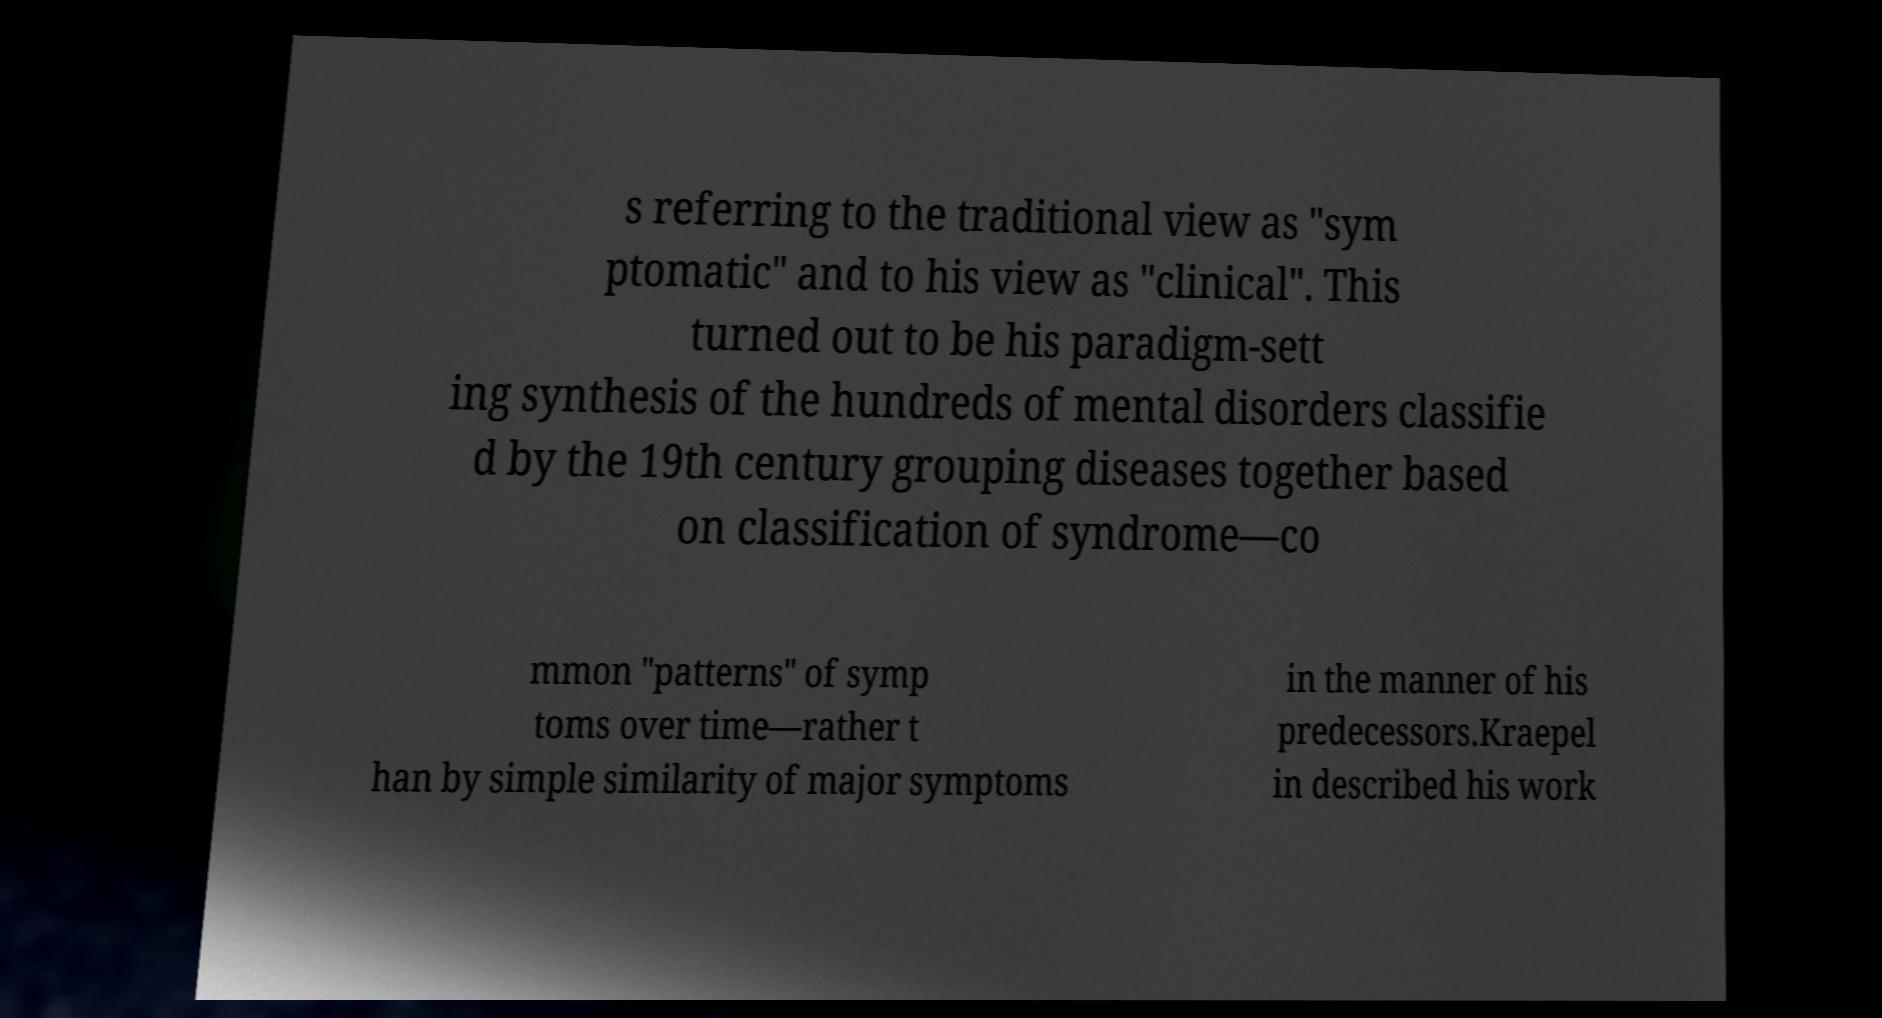There's text embedded in this image that I need extracted. Can you transcribe it verbatim? s referring to the traditional view as "sym ptomatic" and to his view as "clinical". This turned out to be his paradigm-sett ing synthesis of the hundreds of mental disorders classifie d by the 19th century grouping diseases together based on classification of syndrome—co mmon "patterns" of symp toms over time—rather t han by simple similarity of major symptoms in the manner of his predecessors.Kraepel in described his work 